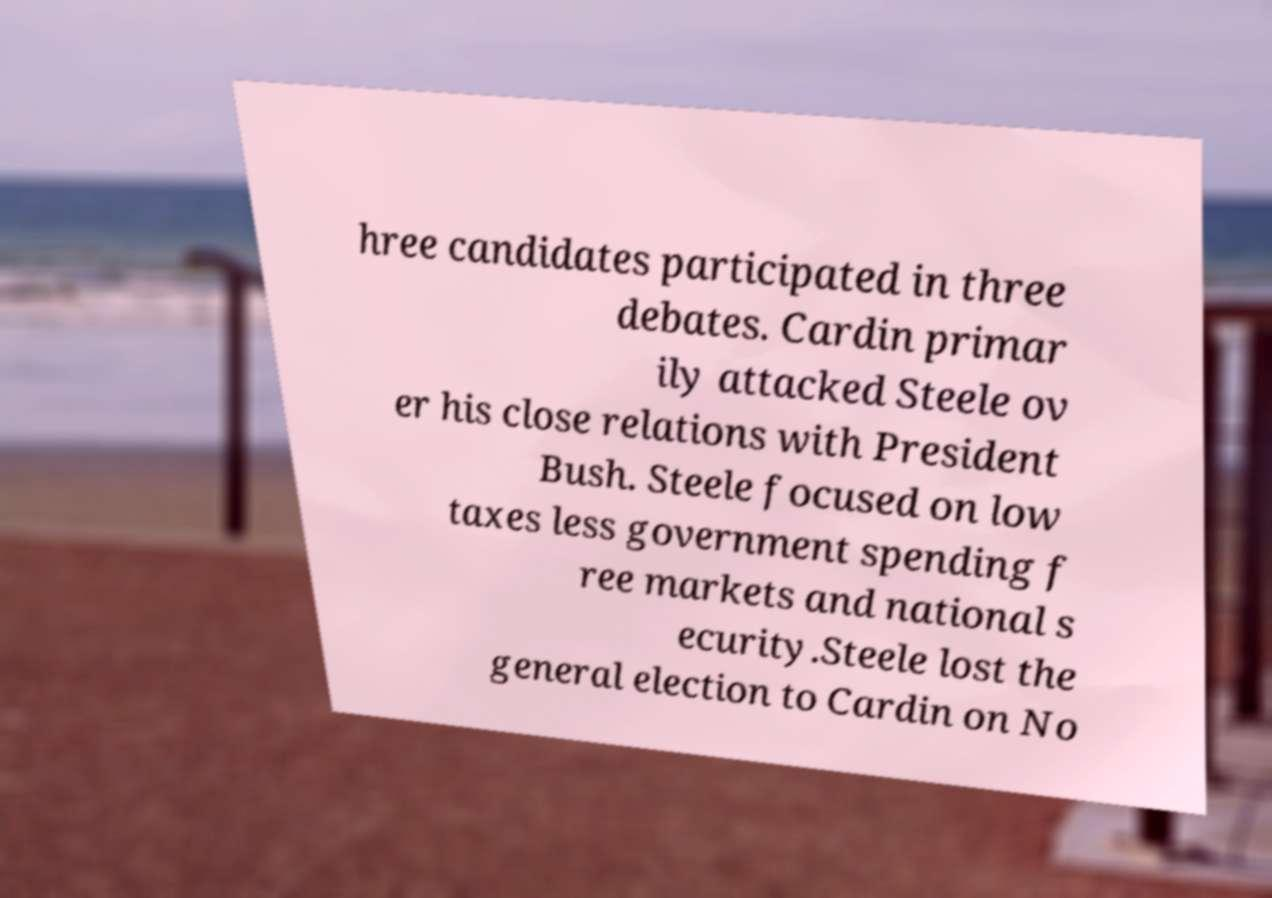Please identify and transcribe the text found in this image. hree candidates participated in three debates. Cardin primar ily attacked Steele ov er his close relations with President Bush. Steele focused on low taxes less government spending f ree markets and national s ecurity.Steele lost the general election to Cardin on No 